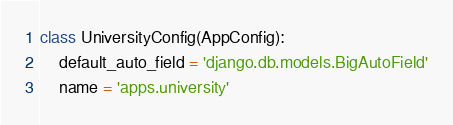<code> <loc_0><loc_0><loc_500><loc_500><_Python_>
class UniversityConfig(AppConfig):
    default_auto_field = 'django.db.models.BigAutoField'
    name = 'apps.university'
</code> 